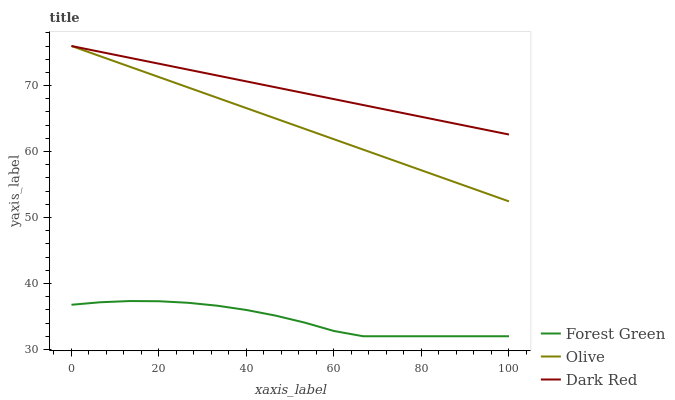Does Forest Green have the minimum area under the curve?
Answer yes or no. Yes. Does Dark Red have the maximum area under the curve?
Answer yes or no. Yes. Does Dark Red have the minimum area under the curve?
Answer yes or no. No. Does Forest Green have the maximum area under the curve?
Answer yes or no. No. Is Olive the smoothest?
Answer yes or no. Yes. Is Forest Green the roughest?
Answer yes or no. Yes. Is Dark Red the smoothest?
Answer yes or no. No. Is Dark Red the roughest?
Answer yes or no. No. Does Dark Red have the lowest value?
Answer yes or no. No. Does Dark Red have the highest value?
Answer yes or no. Yes. Does Forest Green have the highest value?
Answer yes or no. No. Is Forest Green less than Dark Red?
Answer yes or no. Yes. Is Olive greater than Forest Green?
Answer yes or no. Yes. Does Olive intersect Dark Red?
Answer yes or no. Yes. Is Olive less than Dark Red?
Answer yes or no. No. Is Olive greater than Dark Red?
Answer yes or no. No. Does Forest Green intersect Dark Red?
Answer yes or no. No. 